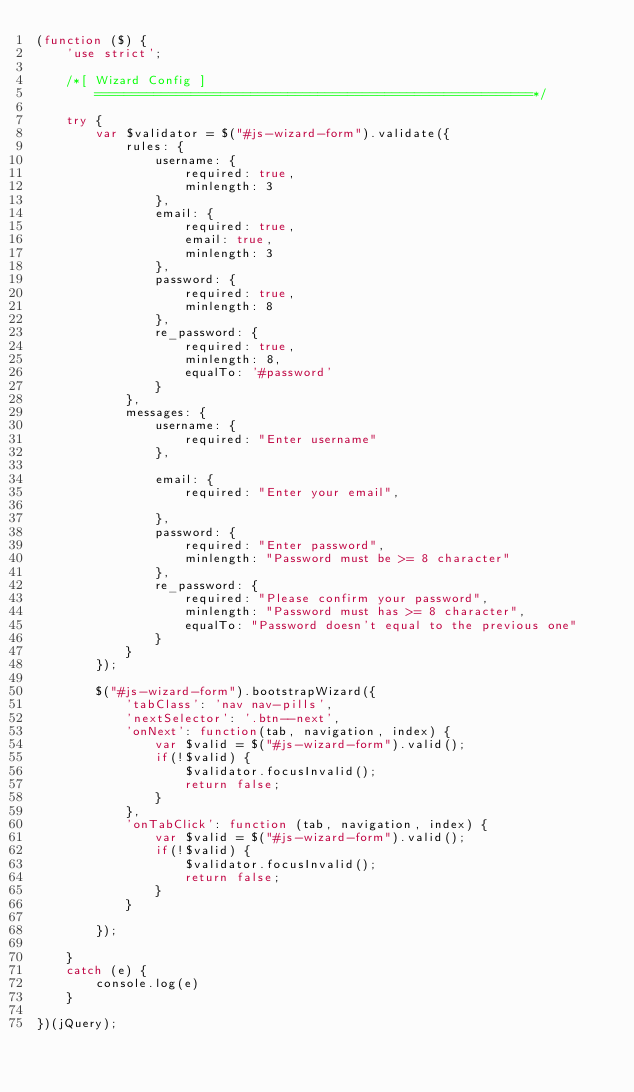Convert code to text. <code><loc_0><loc_0><loc_500><loc_500><_JavaScript_>(function ($) {
    'use strict';

    /*[ Wizard Config ]
        ===========================================================*/
    
    try {
        var $validator = $("#js-wizard-form").validate({
            rules: {
                username: {
                    required: true,
                    minlength: 3
                },
                email: {
                    required: true,
                    email: true,
                    minlength: 3
                },
                password: {
                    required: true,
                    minlength: 8
                },
                re_password: {
                    required: true,
                    minlength: 8,
                    equalTo: '#password'
                }
            },
            messages: {
                username: {
                    required: "Enter username"
                },
    
                email: {
                    required: "Enter your email",
    
                },
                password: {
                    required: "Enter password",
                    minlength: "Password must be >= 8 character"
                },
                re_password: {
                    required: "Please confirm your password",
                    minlength: "Password must has >= 8 character",
                    equalTo: "Password doesn't equal to the previous one"
                }
            }
        });
    
        $("#js-wizard-form").bootstrapWizard({
            'tabClass': 'nav nav-pills',
            'nextSelector': '.btn--next',
            'onNext': function(tab, navigation, index) {
                var $valid = $("#js-wizard-form").valid();
                if(!$valid) {
                    $validator.focusInvalid();
                    return false;
                }
            },
            'onTabClick': function (tab, navigation, index) {
                var $valid = $("#js-wizard-form").valid();
                if(!$valid) {
                    $validator.focusInvalid();
                    return false;
                }
            }
    
        });
    
    }
    catch (e) {
        console.log(e)
    }

})(jQuery);</code> 